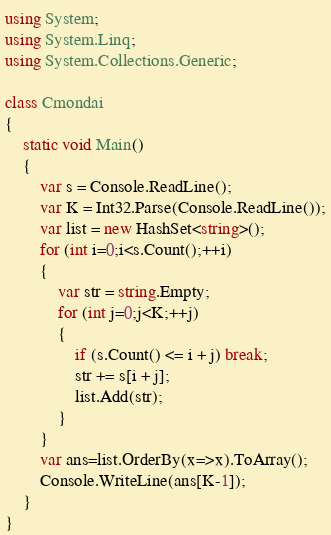<code> <loc_0><loc_0><loc_500><loc_500><_C#_>using System;
using System.Linq;
using System.Collections.Generic;

class Cmondai
{
    static void Main()
    {
        var s = Console.ReadLine();
        var K = Int32.Parse(Console.ReadLine());
        var list = new HashSet<string>();
        for (int i=0;i<s.Count();++i)
        {
            var str = string.Empty;
            for (int j=0;j<K;++j)
            {
                if (s.Count() <= i + j) break;
                str += s[i + j];
                list.Add(str);
            }
        }
        var ans=list.OrderBy(x=>x).ToArray();
        Console.WriteLine(ans[K-1]);
    }
}</code> 